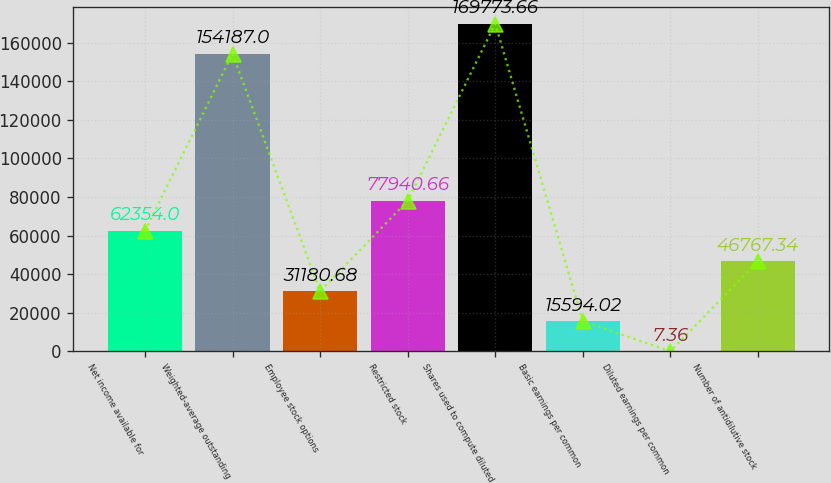Convert chart. <chart><loc_0><loc_0><loc_500><loc_500><bar_chart><fcel>Net income available for<fcel>Weighted-average outstanding<fcel>Employee stock options<fcel>Restricted stock<fcel>Shares used to compute diluted<fcel>Basic earnings per common<fcel>Diluted earnings per common<fcel>Number of antidilutive stock<nl><fcel>62354<fcel>154187<fcel>31180.7<fcel>77940.7<fcel>169774<fcel>15594<fcel>7.36<fcel>46767.3<nl></chart> 